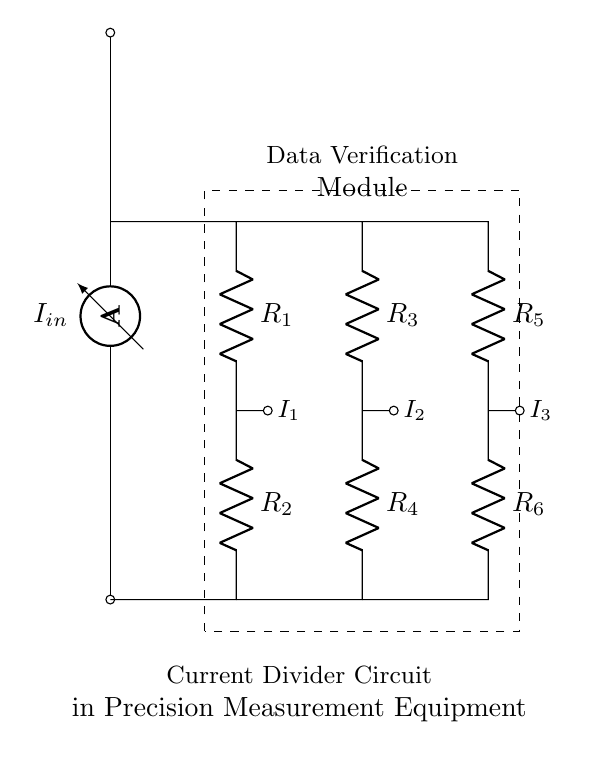What is the type of circuit depicted? The circuit is a current divider, as indicated by multiple resistive branches receiving input current and dividing the current based on their resistances.
Answer: Current Divider How many resistors are in the circuit? The diagram shows six resistors labeled R1, R2, R3, R4, R5, and R6. Counting these labels confirms that there are a total of six resistors.
Answer: Six What is the input current labeled in the diagram? The input current is labeled I_in, which is shown connected to the ammeter at the top of the circuit diagram.
Answer: I_in Which resistors are arranged in series? Resistors R1 and R2 are in series with each other, and R3 and R4 are also in series, just as R5 and R6. This series connection is evident from the direct connection without any branching.
Answer: R1 and R2; R3 and R4; R5 and R6 What can be inferred about the currents I1, I2, and I3 through the resistors? The currents I1, I2, and I3 are the result of the current division based on the resistance values of R1, R2, R3, R4, R5, and R6, meaning each current is inversely proportional to the respective resistance in its branch.
Answer: I1, I2, I3 are divided currents How does the current divider principle apply to this circuit? The current divider principle states that the input current will be divided among the parallel branches in proportion to the resistances; therefore, lower resistance results in higher current. Analyzing the labels and arrangement confirms this principle is applied.
Answer: Current division 